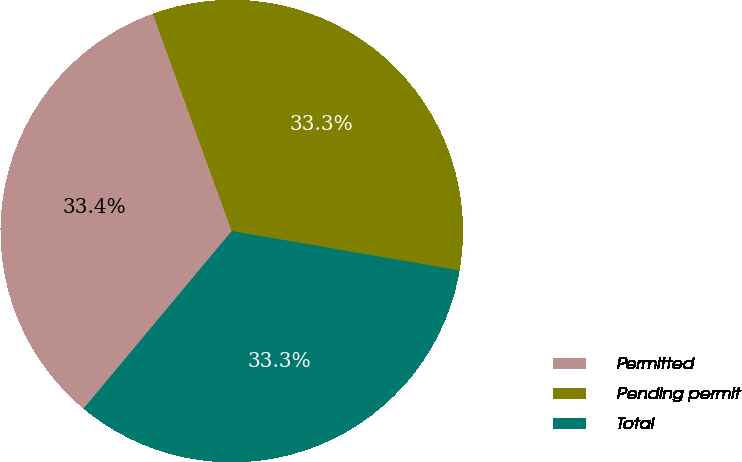<chart> <loc_0><loc_0><loc_500><loc_500><pie_chart><fcel>Permitted<fcel>Pending permit<fcel>Total<nl><fcel>33.39%<fcel>33.27%<fcel>33.34%<nl></chart> 